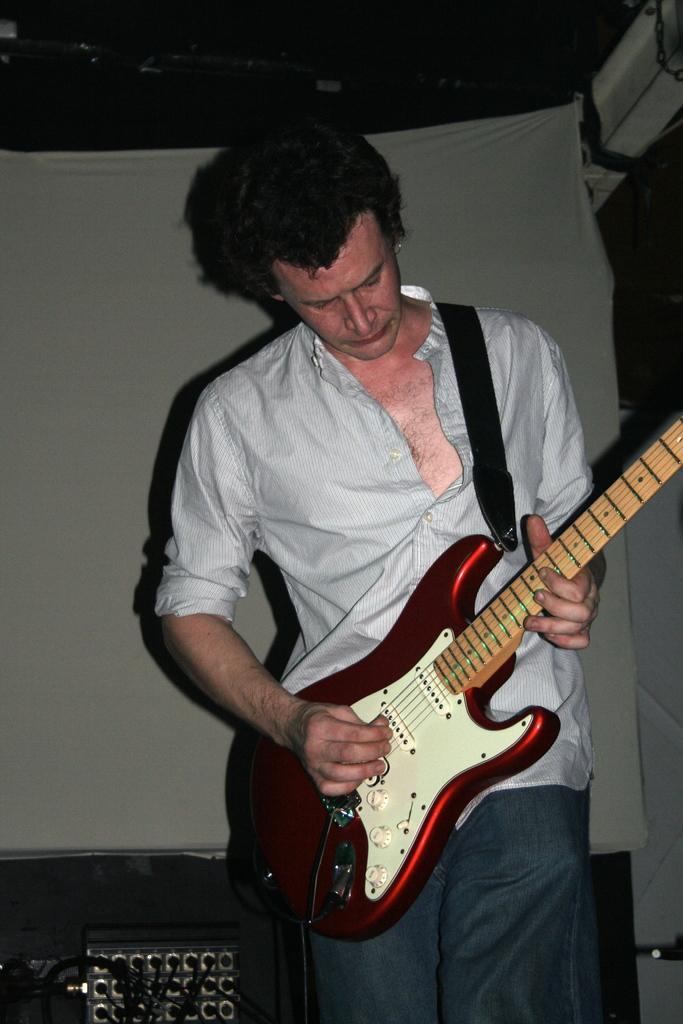How would you summarize this image in a sentence or two? In this image I can see a man is standing and holding a guitar. I can see he is wearing a shirt. 